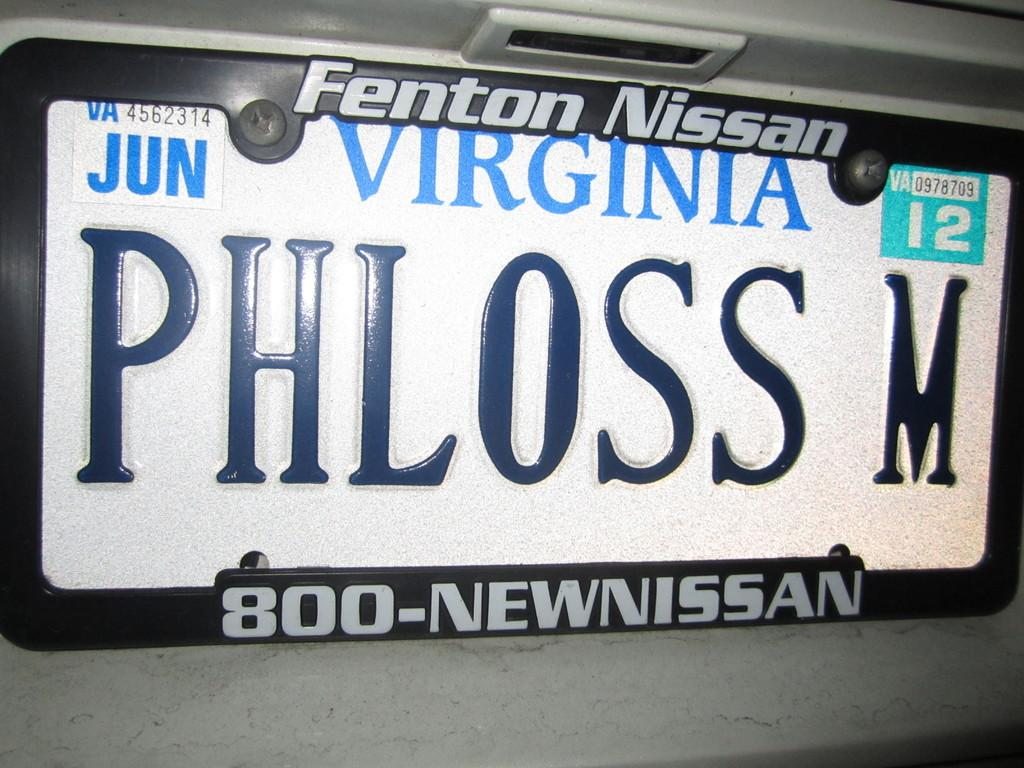<image>
Create a compact narrative representing the image presented. White Virginia license plate which says PHLOSS M on it. 